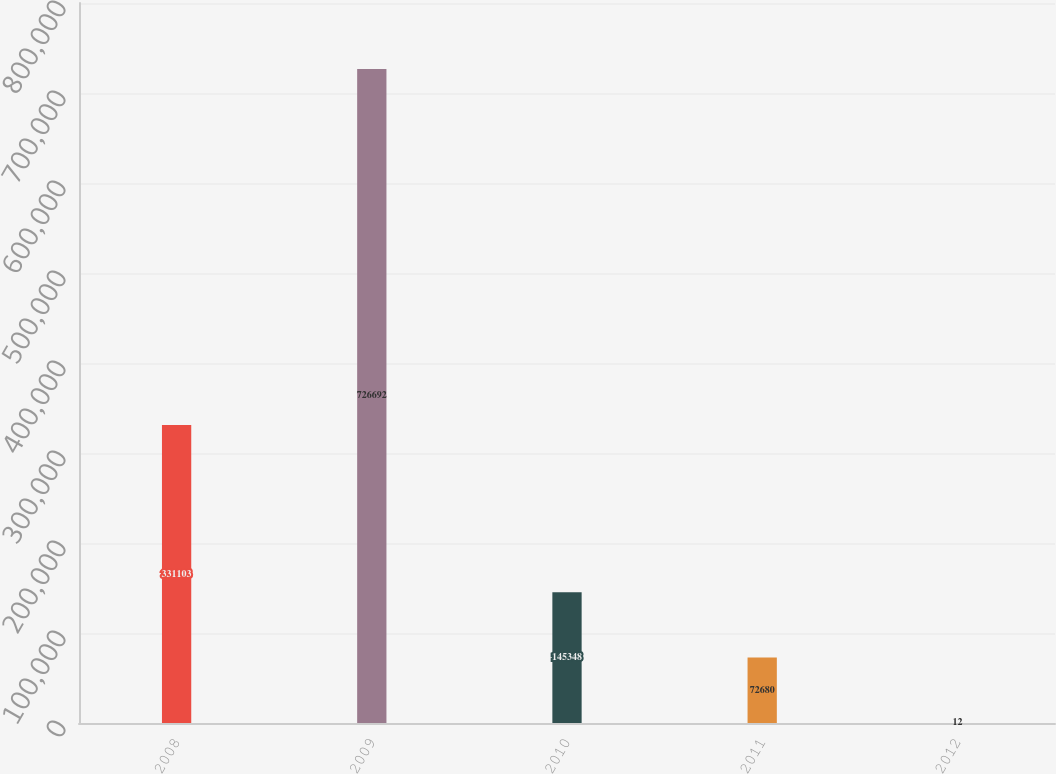Convert chart. <chart><loc_0><loc_0><loc_500><loc_500><bar_chart><fcel>2008<fcel>2009<fcel>2010<fcel>2011<fcel>2012<nl><fcel>331103<fcel>726692<fcel>145348<fcel>72680<fcel>12<nl></chart> 